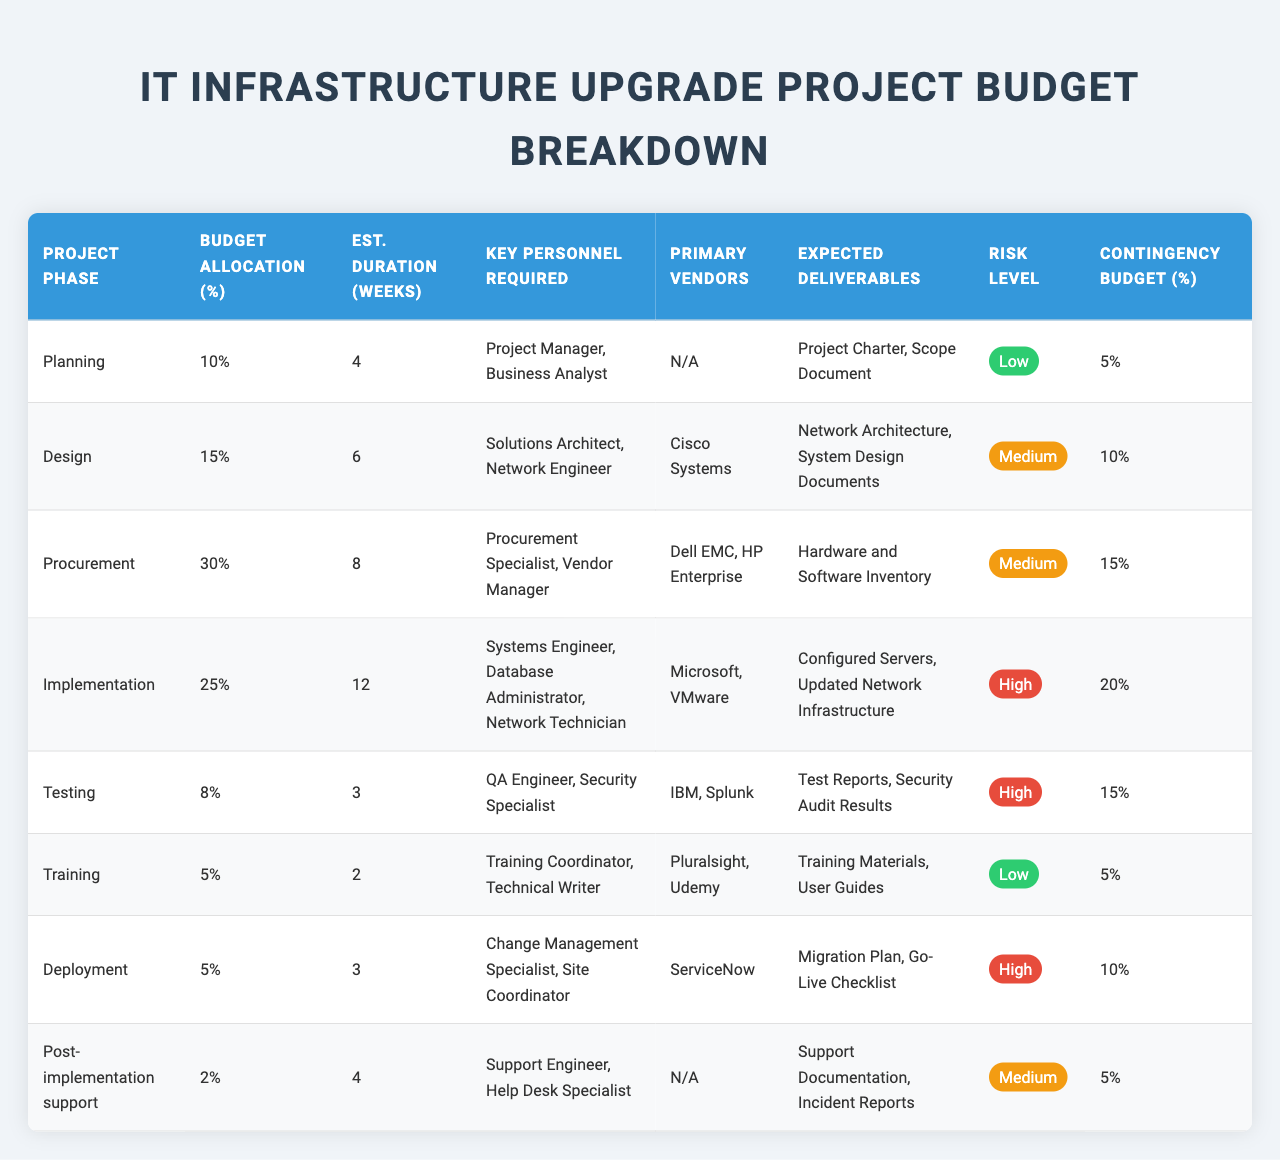What is the budget allocation percentage for the Procurement phase? The Procurement phase has a budget allocation percentage of 30%, which is provided directly in the table.
Answer: 30% Which project phase has the longest estimated duration? The Implementation phase has the longest estimated duration of 12 weeks, which is clearly stated in the estimated duration column in the table.
Answer: Implementation How much total budget is allocated for the Planning and Training phases combined? The budget allocation for Planning is 10% and for Training is 5%. Adding these values together gives 10% + 5% = 15%.
Answer: 15% Is the risk level for the Testing phase considered high? The Testing phase has a risk level classified as high, as indicated in the risk level column of the table.
Answer: Yes What is the contingency budget percentage for the Design and Implementation phases? The contingency budget percentage for Design is 10% and for Implementation is 20%. The total for both phases is 10% + 20% = 30%.
Answer: 30% Which key personnel is required for the Deployment phase? The key personnel required for the Deployment phase are Change Management Specialist and Site Coordinator, as listed in the table.
Answer: Change Management Specialist, Site Coordinator What is the average contingency budget percentage across all phases? The contingency budget percentages are 5%, 10%, 15%, 20%, 15%, 5%, 10%, and 5%. Summing these gives 5 + 10 + 15 + 20 + 15 + 5 + 10 + 5 = 85%. Dividing by 8 phases gives an average of 85% / 8 = 10.625%.
Answer: 10.625% How many phases have a risk level classified as low? According to the table, the phases with a low risk level are Planning and Training, making it a total of 2 phases.
Answer: 2 What are the expected deliverables for the Post-implementation support phase? The expected deliverables for the Post-implementation support phase include Support Documentation and Incident Reports, as indicated in the table.
Answer: Support Documentation, Incident Reports Which project phase has the smallest budget allocation percentage? The Post-implementation support phase has the smallest budget allocation at 2%, which can be observed in the corresponding column of the table.
Answer: 2% What is the total estimated duration for the phases classified as having a high-risk level? The estimated durations for the high-risk phases (Implementation, Testing, and Deployment) are 12 weeks, 3 weeks, and 3 weeks respectively, totaling 12 + 3 + 3 = 18 weeks.
Answer: 18 weeks 